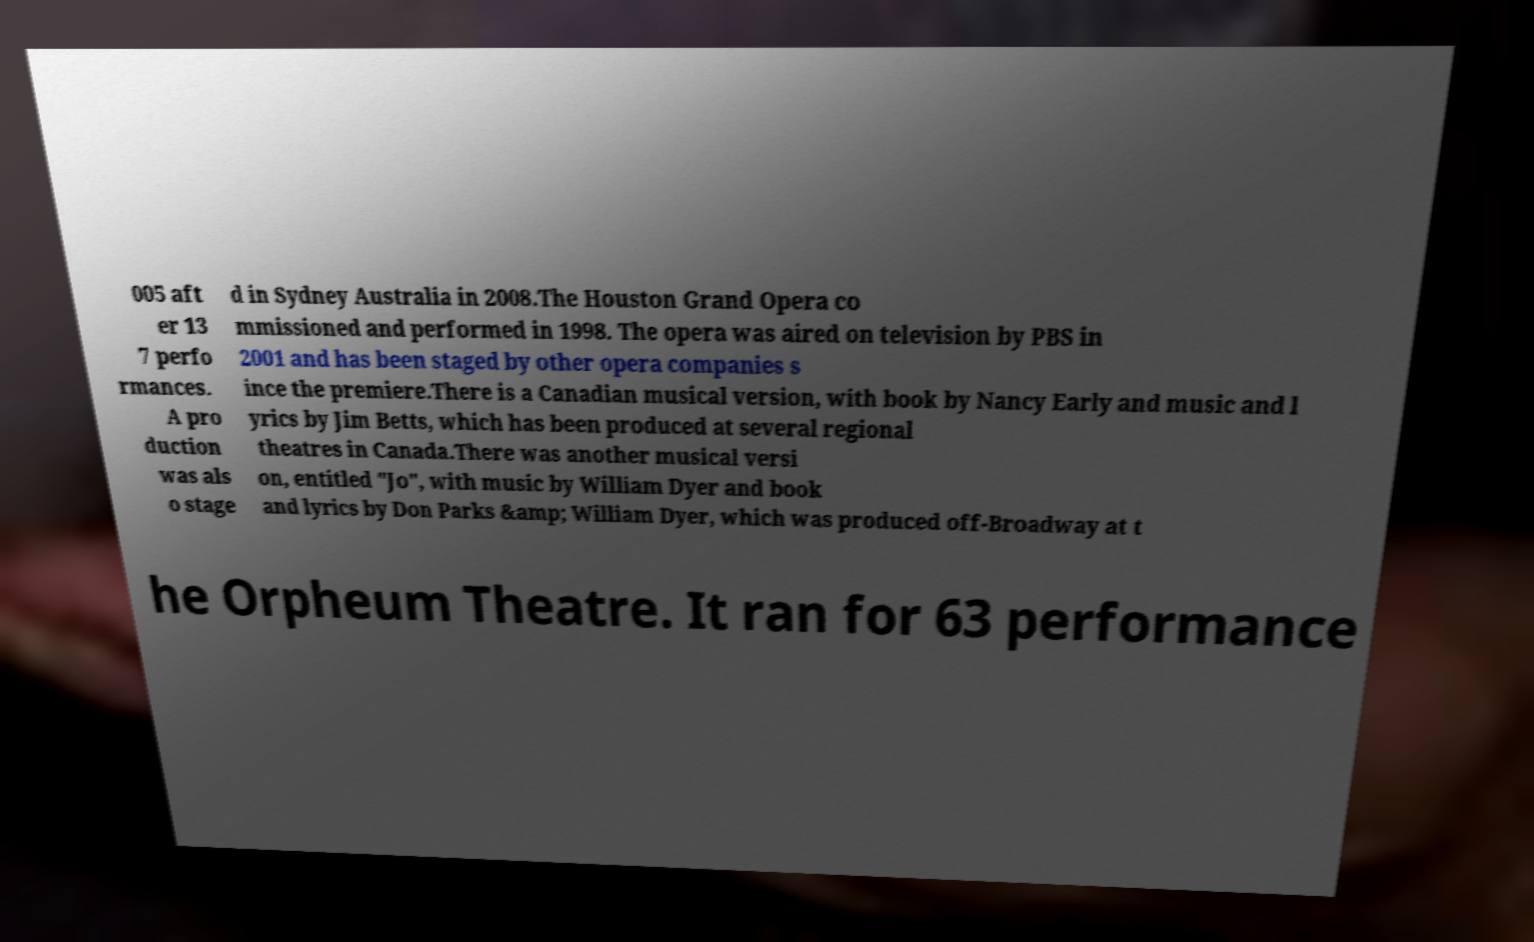Could you assist in decoding the text presented in this image and type it out clearly? 005 aft er 13 7 perfo rmances. A pro duction was als o stage d in Sydney Australia in 2008.The Houston Grand Opera co mmissioned and performed in 1998. The opera was aired on television by PBS in 2001 and has been staged by other opera companies s ince the premiere.There is a Canadian musical version, with book by Nancy Early and music and l yrics by Jim Betts, which has been produced at several regional theatres in Canada.There was another musical versi on, entitled "Jo", with music by William Dyer and book and lyrics by Don Parks &amp; William Dyer, which was produced off-Broadway at t he Orpheum Theatre. It ran for 63 performance 